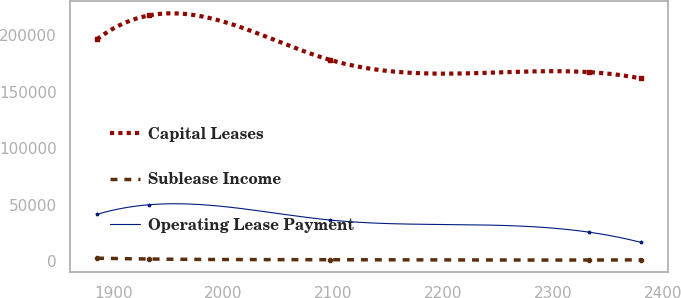Convert chart. <chart><loc_0><loc_0><loc_500><loc_500><line_chart><ecel><fcel>Capital Leases<fcel>Sublease Income<fcel>Operating Lease Payment<nl><fcel>1885.38<fcel>196173<fcel>2897.3<fcel>41572.4<nl><fcel>1932.53<fcel>217143<fcel>2166.55<fcel>50042<nl><fcel>2097.58<fcel>177841<fcel>1587.59<fcel>36541.6<nl><fcel>2332.9<fcel>167105<fcel>1256.47<fcel>25885.7<nl><fcel>2380.05<fcel>161545<fcel>1420.55<fcel>16878.6<nl></chart> 